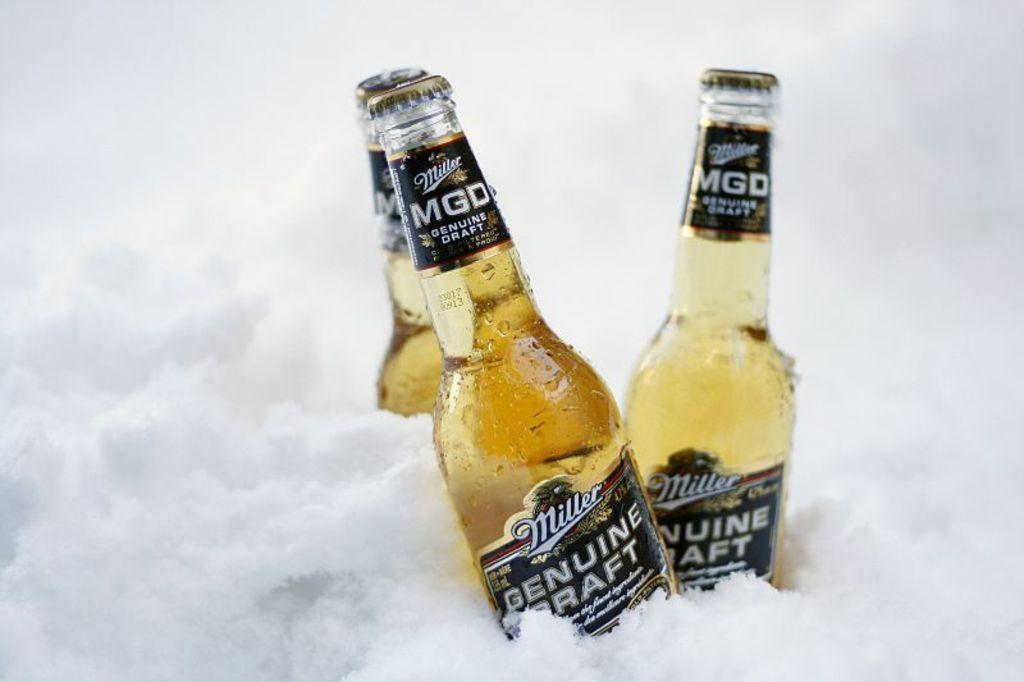How many bottles are visible in the image? There are three bottles in the image. What is the bottles' location within the image? The bottles are inside a block of ice. What type of lamp is visible in the image? There is no lamp present in the image. What might cause the bottles to stop suddenly in the image? The bottles are inside a block of ice, so there is no need for a brake. 